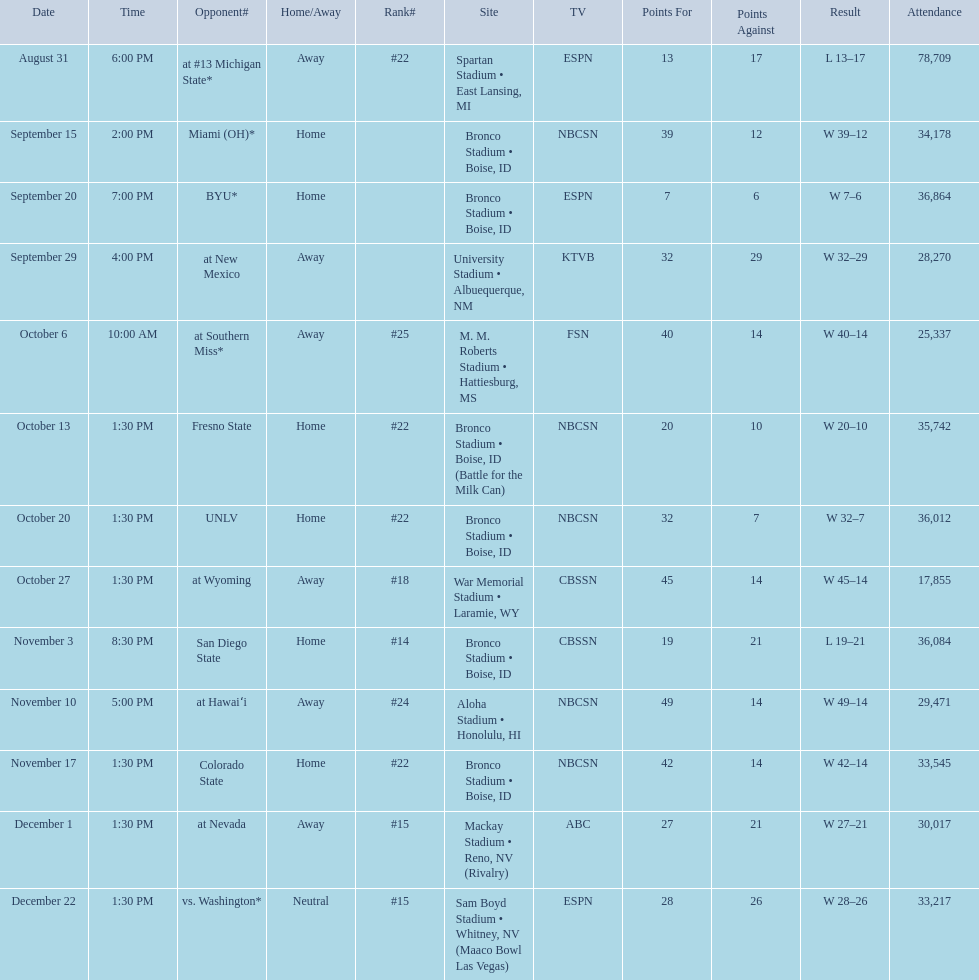What are the opponent teams of the 2012 boise state broncos football team? At #13 michigan state*, miami (oh)*, byu*, at new mexico, at southern miss*, fresno state, unlv, at wyoming, san diego state, at hawaiʻi, colorado state, at nevada, vs. washington*. How has the highest rank of these opponents? San Diego State. 